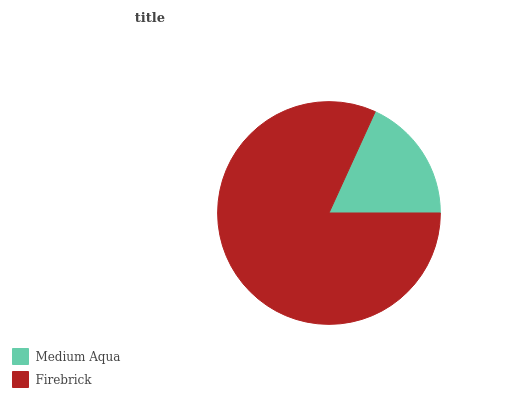Is Medium Aqua the minimum?
Answer yes or no. Yes. Is Firebrick the maximum?
Answer yes or no. Yes. Is Firebrick the minimum?
Answer yes or no. No. Is Firebrick greater than Medium Aqua?
Answer yes or no. Yes. Is Medium Aqua less than Firebrick?
Answer yes or no. Yes. Is Medium Aqua greater than Firebrick?
Answer yes or no. No. Is Firebrick less than Medium Aqua?
Answer yes or no. No. Is Firebrick the high median?
Answer yes or no. Yes. Is Medium Aqua the low median?
Answer yes or no. Yes. Is Medium Aqua the high median?
Answer yes or no. No. Is Firebrick the low median?
Answer yes or no. No. 